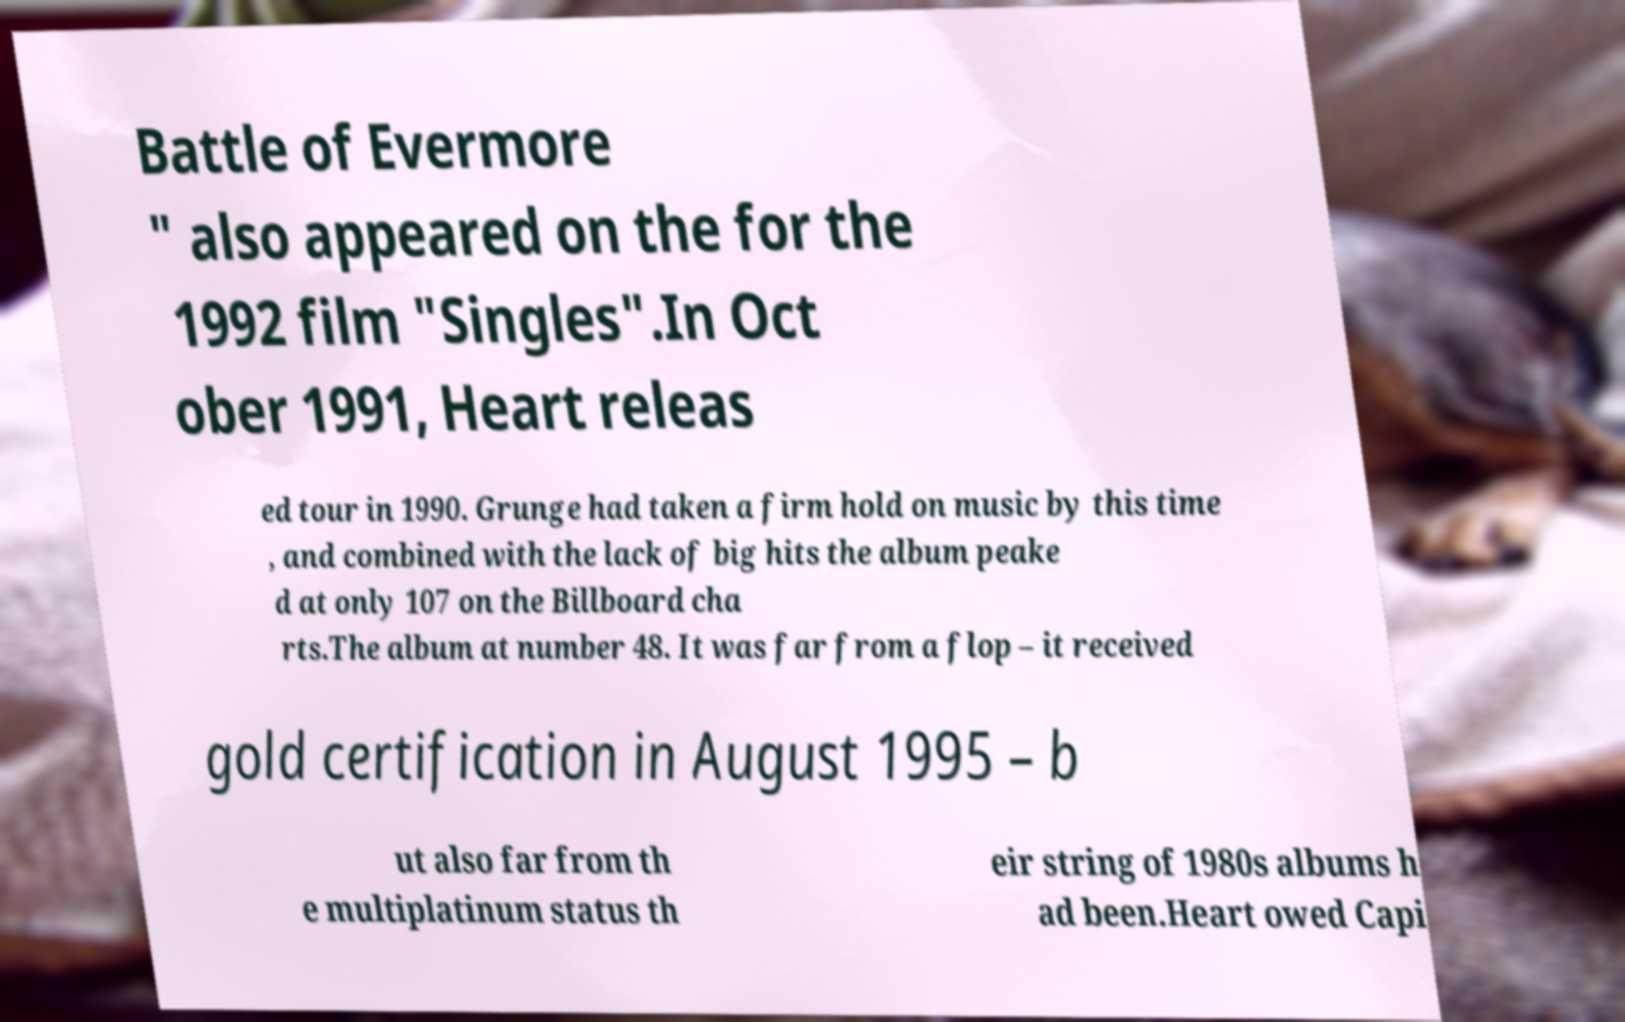Can you accurately transcribe the text from the provided image for me? Battle of Evermore " also appeared on the for the 1992 film "Singles".In Oct ober 1991, Heart releas ed tour in 1990. Grunge had taken a firm hold on music by this time , and combined with the lack of big hits the album peake d at only 107 on the Billboard cha rts.The album at number 48. It was far from a flop – it received gold certification in August 1995 – b ut also far from th e multiplatinum status th eir string of 1980s albums h ad been.Heart owed Capi 